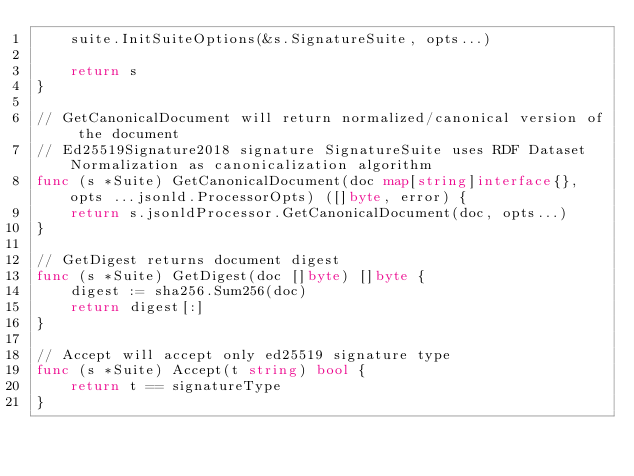<code> <loc_0><loc_0><loc_500><loc_500><_Go_>	suite.InitSuiteOptions(&s.SignatureSuite, opts...)

	return s
}

// GetCanonicalDocument will return normalized/canonical version of the document
// Ed25519Signature2018 signature SignatureSuite uses RDF Dataset Normalization as canonicalization algorithm
func (s *Suite) GetCanonicalDocument(doc map[string]interface{}, opts ...jsonld.ProcessorOpts) ([]byte, error) {
	return s.jsonldProcessor.GetCanonicalDocument(doc, opts...)
}

// GetDigest returns document digest
func (s *Suite) GetDigest(doc []byte) []byte {
	digest := sha256.Sum256(doc)
	return digest[:]
}

// Accept will accept only ed25519 signature type
func (s *Suite) Accept(t string) bool {
	return t == signatureType
}
</code> 